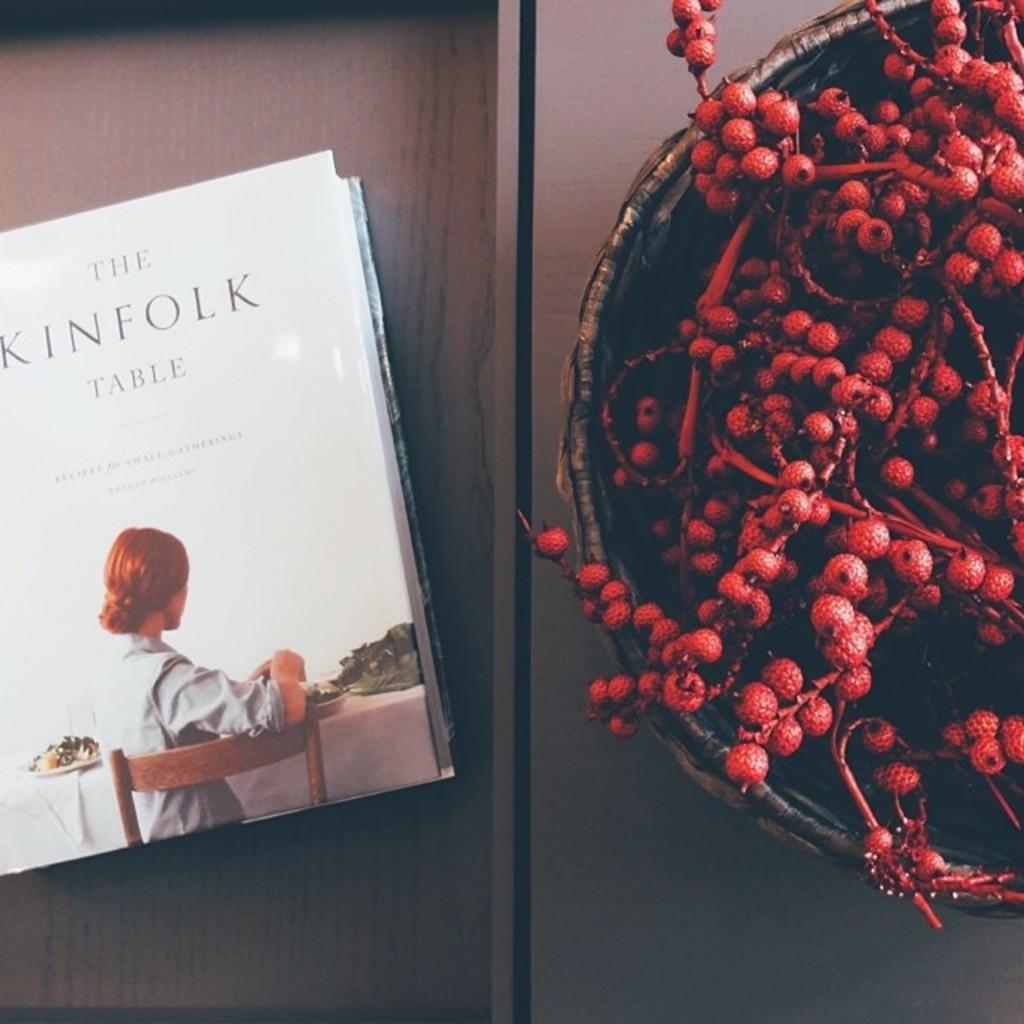What is the kinfolk object referenced on this book cover?
Make the answer very short. Table. 